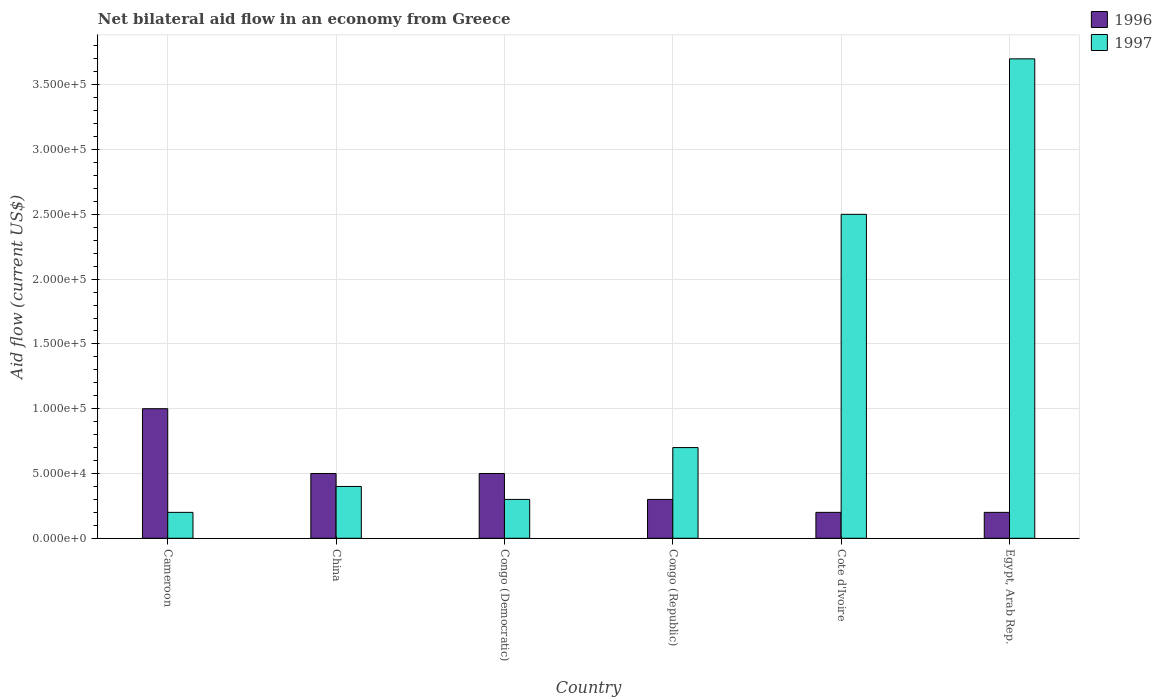How many different coloured bars are there?
Your answer should be compact. 2. How many groups of bars are there?
Make the answer very short. 6. Are the number of bars per tick equal to the number of legend labels?
Give a very brief answer. Yes. Are the number of bars on each tick of the X-axis equal?
Give a very brief answer. Yes. How many bars are there on the 6th tick from the left?
Offer a very short reply. 2. In how many cases, is the number of bars for a given country not equal to the number of legend labels?
Your answer should be compact. 0. Across all countries, what is the minimum net bilateral aid flow in 1996?
Your response must be concise. 2.00e+04. In which country was the net bilateral aid flow in 1997 maximum?
Offer a terse response. Egypt, Arab Rep. In which country was the net bilateral aid flow in 1996 minimum?
Provide a short and direct response. Cote d'Ivoire. What is the total net bilateral aid flow in 1996 in the graph?
Ensure brevity in your answer.  2.70e+05. What is the difference between the net bilateral aid flow in 1997 in China and the net bilateral aid flow in 1996 in Cameroon?
Keep it short and to the point. -6.00e+04. What is the average net bilateral aid flow in 1996 per country?
Offer a terse response. 4.50e+04. In how many countries, is the net bilateral aid flow in 1997 greater than 180000 US$?
Keep it short and to the point. 2. What is the ratio of the net bilateral aid flow in 1996 in Cameroon to that in Congo (Republic)?
Offer a very short reply. 3.33. Is the difference between the net bilateral aid flow in 1996 in Cameroon and Cote d'Ivoire greater than the difference between the net bilateral aid flow in 1997 in Cameroon and Cote d'Ivoire?
Provide a short and direct response. Yes. What is the difference between the highest and the lowest net bilateral aid flow in 1996?
Make the answer very short. 8.00e+04. In how many countries, is the net bilateral aid flow in 1996 greater than the average net bilateral aid flow in 1996 taken over all countries?
Provide a succinct answer. 3. Is the sum of the net bilateral aid flow in 1997 in Cameroon and Cote d'Ivoire greater than the maximum net bilateral aid flow in 1996 across all countries?
Keep it short and to the point. Yes. What does the 2nd bar from the right in Cameroon represents?
Provide a short and direct response. 1996. How many countries are there in the graph?
Your answer should be compact. 6. What is the difference between two consecutive major ticks on the Y-axis?
Provide a short and direct response. 5.00e+04. Does the graph contain any zero values?
Make the answer very short. No. Does the graph contain grids?
Ensure brevity in your answer.  Yes. How many legend labels are there?
Your answer should be compact. 2. What is the title of the graph?
Offer a terse response. Net bilateral aid flow in an economy from Greece. Does "1985" appear as one of the legend labels in the graph?
Your answer should be very brief. No. What is the Aid flow (current US$) in 1997 in Cameroon?
Your response must be concise. 2.00e+04. What is the Aid flow (current US$) of 1996 in Congo (Democratic)?
Offer a terse response. 5.00e+04. What is the Aid flow (current US$) in 1996 in Congo (Republic)?
Your answer should be very brief. 3.00e+04. What is the Aid flow (current US$) in 1996 in Egypt, Arab Rep.?
Provide a short and direct response. 2.00e+04. What is the Aid flow (current US$) of 1997 in Egypt, Arab Rep.?
Ensure brevity in your answer.  3.70e+05. Across all countries, what is the maximum Aid flow (current US$) in 1996?
Your answer should be very brief. 1.00e+05. Across all countries, what is the minimum Aid flow (current US$) of 1996?
Keep it short and to the point. 2.00e+04. What is the total Aid flow (current US$) of 1997 in the graph?
Make the answer very short. 7.80e+05. What is the difference between the Aid flow (current US$) of 1996 in Cameroon and that in China?
Give a very brief answer. 5.00e+04. What is the difference between the Aid flow (current US$) in 1997 in Cameroon and that in China?
Make the answer very short. -2.00e+04. What is the difference between the Aid flow (current US$) of 1996 in Cameroon and that in Cote d'Ivoire?
Provide a succinct answer. 8.00e+04. What is the difference between the Aid flow (current US$) in 1997 in Cameroon and that in Egypt, Arab Rep.?
Keep it short and to the point. -3.50e+05. What is the difference between the Aid flow (current US$) of 1996 in China and that in Congo (Democratic)?
Your answer should be very brief. 0. What is the difference between the Aid flow (current US$) of 1997 in China and that in Congo (Democratic)?
Your answer should be compact. 10000. What is the difference between the Aid flow (current US$) in 1996 in China and that in Congo (Republic)?
Your answer should be very brief. 2.00e+04. What is the difference between the Aid flow (current US$) of 1997 in China and that in Congo (Republic)?
Give a very brief answer. -3.00e+04. What is the difference between the Aid flow (current US$) of 1996 in China and that in Cote d'Ivoire?
Offer a very short reply. 3.00e+04. What is the difference between the Aid flow (current US$) of 1997 in China and that in Cote d'Ivoire?
Keep it short and to the point. -2.10e+05. What is the difference between the Aid flow (current US$) of 1997 in China and that in Egypt, Arab Rep.?
Your response must be concise. -3.30e+05. What is the difference between the Aid flow (current US$) in 1997 in Congo (Democratic) and that in Cote d'Ivoire?
Keep it short and to the point. -2.20e+05. What is the difference between the Aid flow (current US$) of 1996 in Congo (Republic) and that in Cote d'Ivoire?
Your answer should be very brief. 10000. What is the difference between the Aid flow (current US$) of 1996 in Congo (Republic) and that in Egypt, Arab Rep.?
Offer a terse response. 10000. What is the difference between the Aid flow (current US$) in 1997 in Congo (Republic) and that in Egypt, Arab Rep.?
Offer a terse response. -3.00e+05. What is the difference between the Aid flow (current US$) of 1996 in Cote d'Ivoire and that in Egypt, Arab Rep.?
Provide a short and direct response. 0. What is the difference between the Aid flow (current US$) in 1996 in Cameroon and the Aid flow (current US$) in 1997 in Congo (Republic)?
Provide a succinct answer. 3.00e+04. What is the difference between the Aid flow (current US$) in 1996 in Cameroon and the Aid flow (current US$) in 1997 in Cote d'Ivoire?
Give a very brief answer. -1.50e+05. What is the difference between the Aid flow (current US$) in 1996 in China and the Aid flow (current US$) in 1997 in Congo (Republic)?
Make the answer very short. -2.00e+04. What is the difference between the Aid flow (current US$) of 1996 in China and the Aid flow (current US$) of 1997 in Egypt, Arab Rep.?
Your answer should be very brief. -3.20e+05. What is the difference between the Aid flow (current US$) of 1996 in Congo (Democratic) and the Aid flow (current US$) of 1997 in Egypt, Arab Rep.?
Your answer should be compact. -3.20e+05. What is the difference between the Aid flow (current US$) of 1996 in Congo (Republic) and the Aid flow (current US$) of 1997 in Cote d'Ivoire?
Your response must be concise. -2.20e+05. What is the difference between the Aid flow (current US$) in 1996 in Congo (Republic) and the Aid flow (current US$) in 1997 in Egypt, Arab Rep.?
Ensure brevity in your answer.  -3.40e+05. What is the difference between the Aid flow (current US$) of 1996 in Cote d'Ivoire and the Aid flow (current US$) of 1997 in Egypt, Arab Rep.?
Offer a very short reply. -3.50e+05. What is the average Aid flow (current US$) of 1996 per country?
Make the answer very short. 4.50e+04. What is the difference between the Aid flow (current US$) of 1996 and Aid flow (current US$) of 1997 in Egypt, Arab Rep.?
Your response must be concise. -3.50e+05. What is the ratio of the Aid flow (current US$) of 1997 in Cameroon to that in Congo (Democratic)?
Ensure brevity in your answer.  0.67. What is the ratio of the Aid flow (current US$) of 1997 in Cameroon to that in Congo (Republic)?
Offer a very short reply. 0.29. What is the ratio of the Aid flow (current US$) in 1997 in Cameroon to that in Cote d'Ivoire?
Keep it short and to the point. 0.08. What is the ratio of the Aid flow (current US$) of 1997 in Cameroon to that in Egypt, Arab Rep.?
Offer a very short reply. 0.05. What is the ratio of the Aid flow (current US$) of 1996 in China to that in Congo (Republic)?
Keep it short and to the point. 1.67. What is the ratio of the Aid flow (current US$) in 1997 in China to that in Congo (Republic)?
Offer a very short reply. 0.57. What is the ratio of the Aid flow (current US$) in 1996 in China to that in Cote d'Ivoire?
Your response must be concise. 2.5. What is the ratio of the Aid flow (current US$) in 1997 in China to that in Cote d'Ivoire?
Give a very brief answer. 0.16. What is the ratio of the Aid flow (current US$) in 1997 in China to that in Egypt, Arab Rep.?
Provide a short and direct response. 0.11. What is the ratio of the Aid flow (current US$) in 1997 in Congo (Democratic) to that in Congo (Republic)?
Your response must be concise. 0.43. What is the ratio of the Aid flow (current US$) of 1997 in Congo (Democratic) to that in Cote d'Ivoire?
Make the answer very short. 0.12. What is the ratio of the Aid flow (current US$) in 1997 in Congo (Democratic) to that in Egypt, Arab Rep.?
Make the answer very short. 0.08. What is the ratio of the Aid flow (current US$) of 1996 in Congo (Republic) to that in Cote d'Ivoire?
Offer a very short reply. 1.5. What is the ratio of the Aid flow (current US$) of 1997 in Congo (Republic) to that in Cote d'Ivoire?
Make the answer very short. 0.28. What is the ratio of the Aid flow (current US$) of 1997 in Congo (Republic) to that in Egypt, Arab Rep.?
Your answer should be compact. 0.19. What is the ratio of the Aid flow (current US$) of 1996 in Cote d'Ivoire to that in Egypt, Arab Rep.?
Provide a short and direct response. 1. What is the ratio of the Aid flow (current US$) of 1997 in Cote d'Ivoire to that in Egypt, Arab Rep.?
Your answer should be compact. 0.68. What is the difference between the highest and the second highest Aid flow (current US$) of 1996?
Offer a terse response. 5.00e+04. What is the difference between the highest and the second highest Aid flow (current US$) of 1997?
Offer a very short reply. 1.20e+05. 